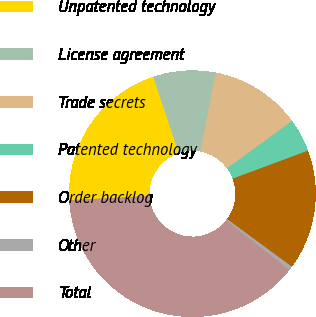Convert chart. <chart><loc_0><loc_0><loc_500><loc_500><pie_chart><fcel>Unpatented technology<fcel>License agreement<fcel>Trade secrets<fcel>Patented technology<fcel>Order backlog<fcel>Other<fcel>Total<nl><fcel>20.71%<fcel>8.16%<fcel>11.95%<fcel>4.36%<fcel>15.75%<fcel>0.57%<fcel>38.51%<nl></chart> 